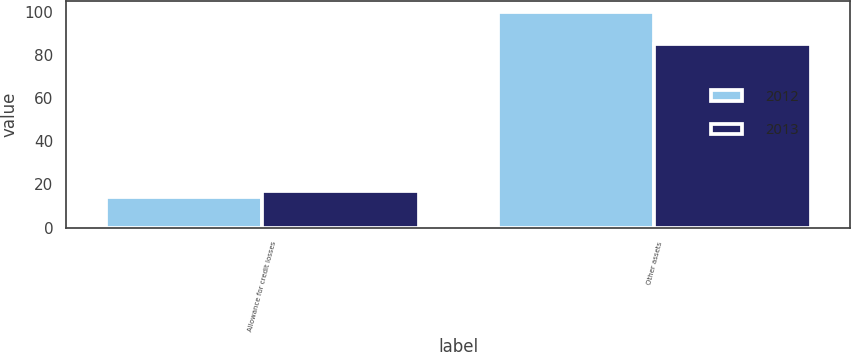Convert chart. <chart><loc_0><loc_0><loc_500><loc_500><stacked_bar_chart><ecel><fcel>Allowance for credit losses<fcel>Other assets<nl><fcel>2012<fcel>14<fcel>100<nl><fcel>2013<fcel>17<fcel>85<nl></chart> 